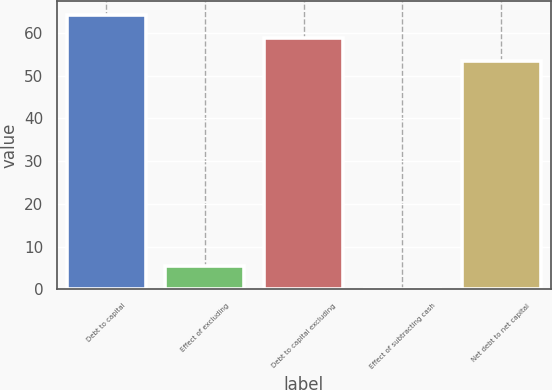Convert chart. <chart><loc_0><loc_0><loc_500><loc_500><bar_chart><fcel>Debt to capital<fcel>Effect of excluding<fcel>Debt to capital excluding<fcel>Effect of subtracting cash<fcel>Net debt to net capital<nl><fcel>64.14<fcel>5.47<fcel>58.77<fcel>0.1<fcel>53.4<nl></chart> 